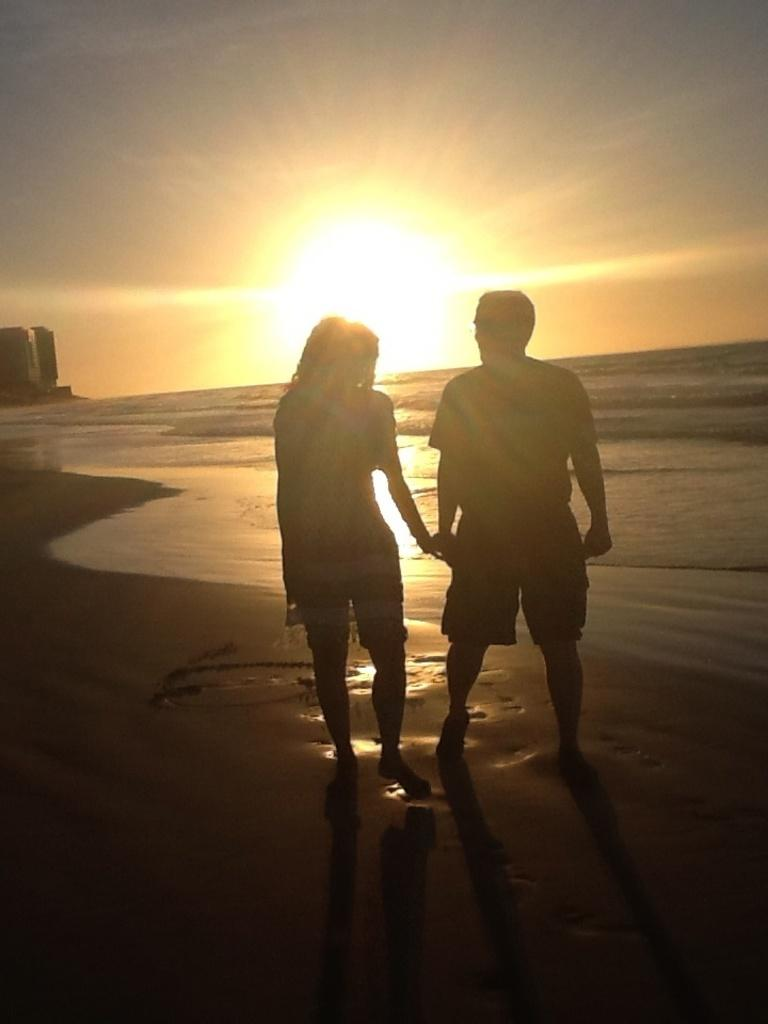How many people are standing on the seashore in the image? There are two people standing on the seashore in the image. What is in front of the people? There is a sea in front of the people. What is visible at the top of the image? The sky is visible at the top of the image. What is the condition of the sky in the image? Sunlight is present in the sky. What is the income of the boys in the image? There are no boys present in the image, and therefore no information about their income can be provided. 